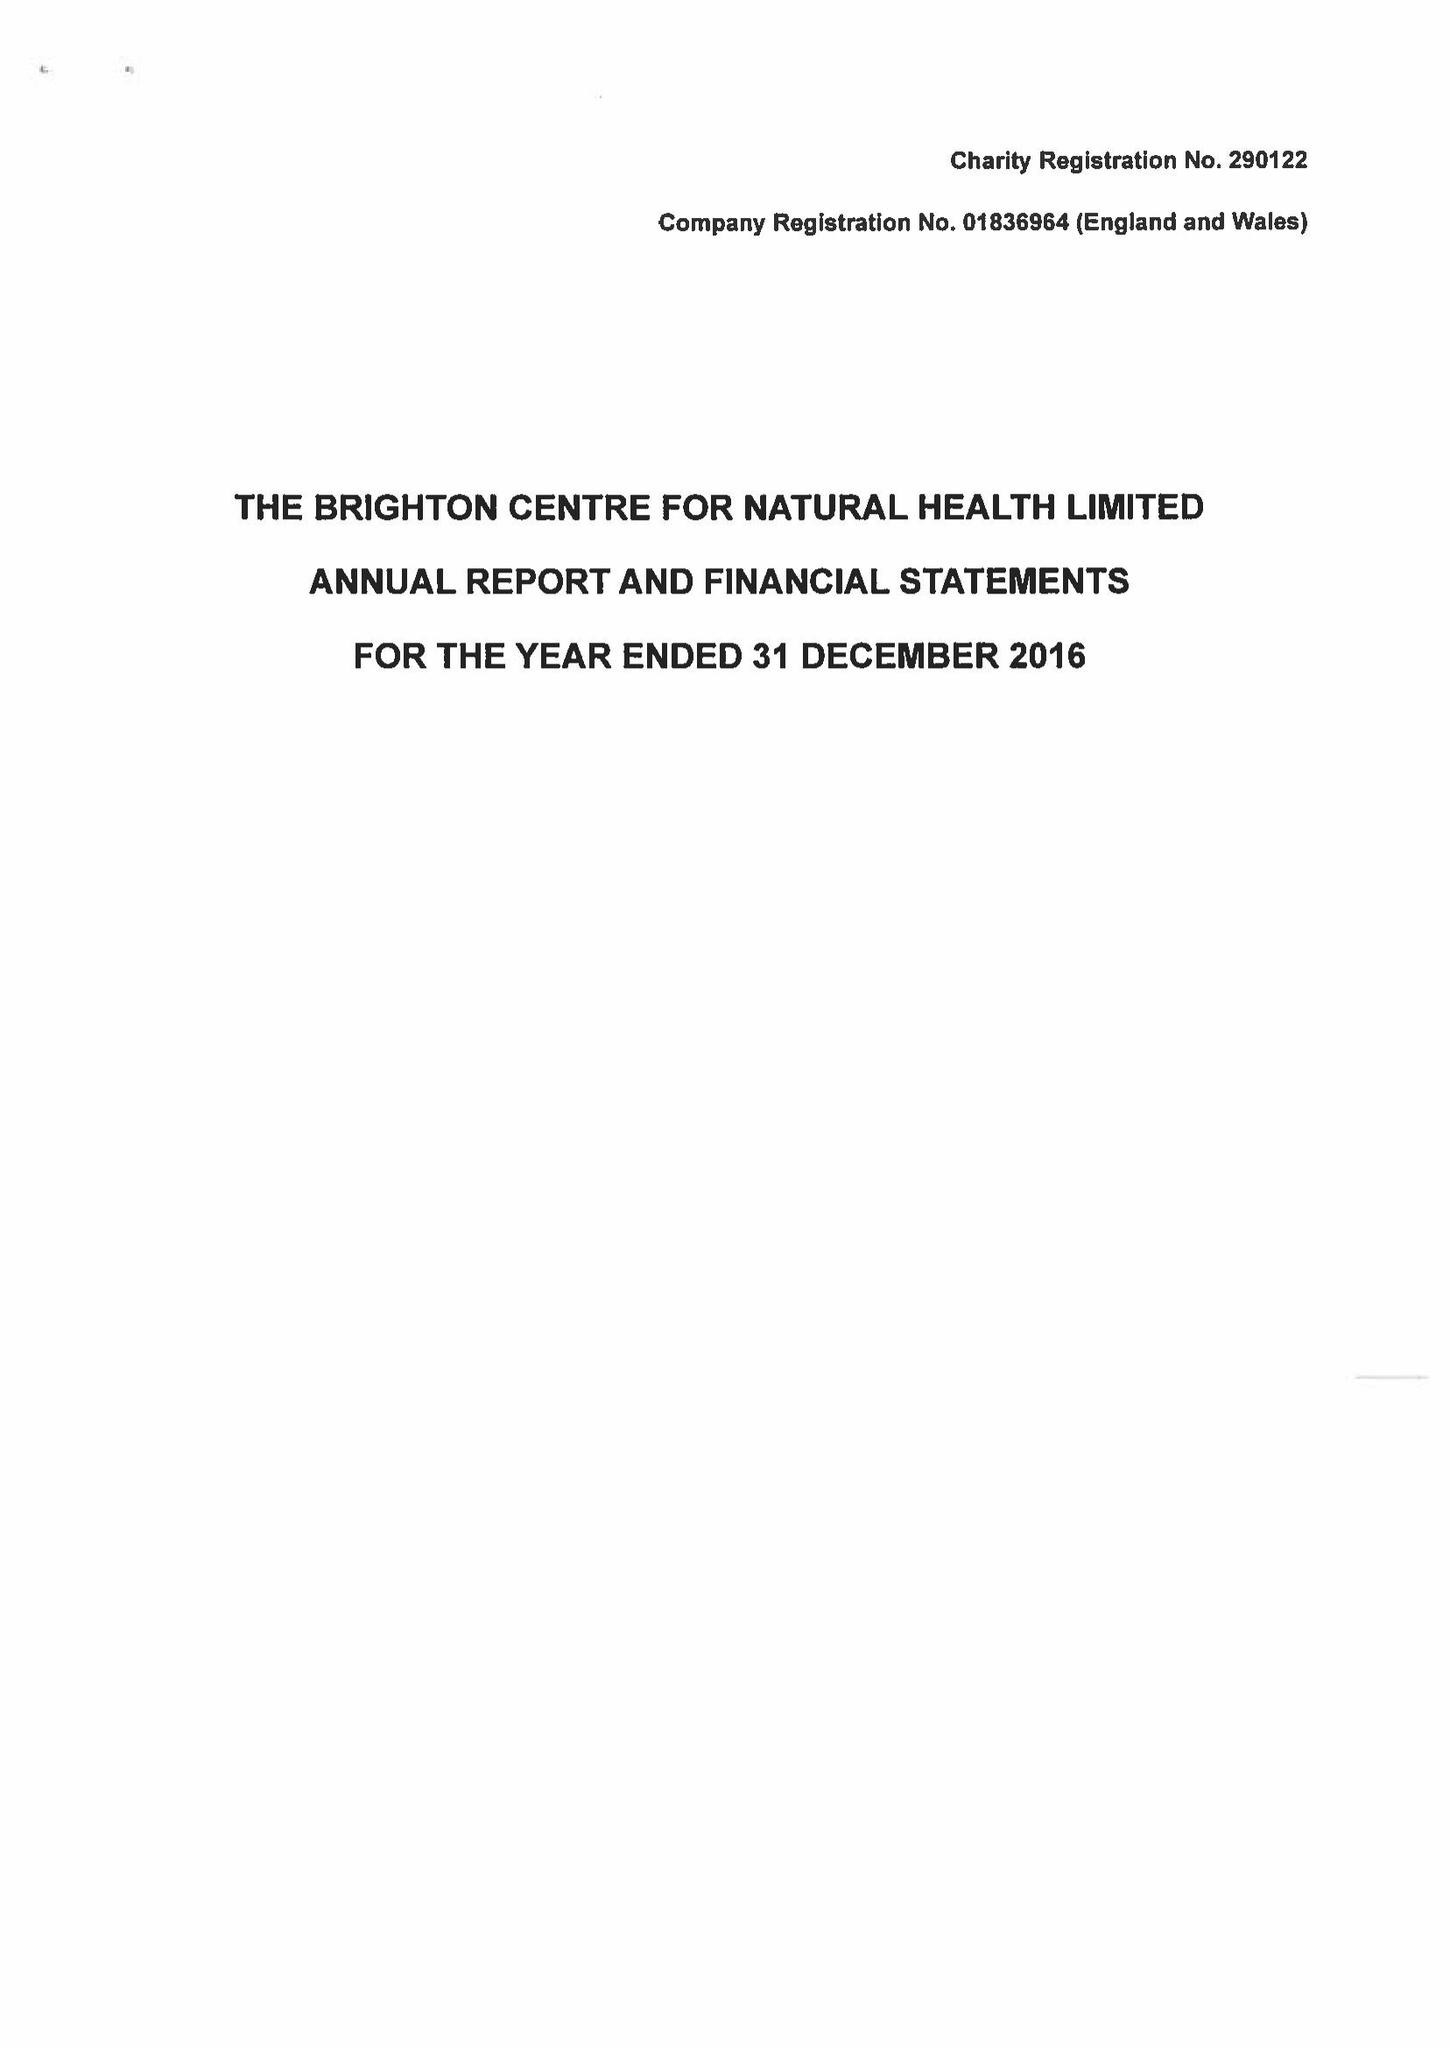What is the value for the charity_name?
Answer the question using a single word or phrase. The Brighton Centre For Natural Health Ltd. 